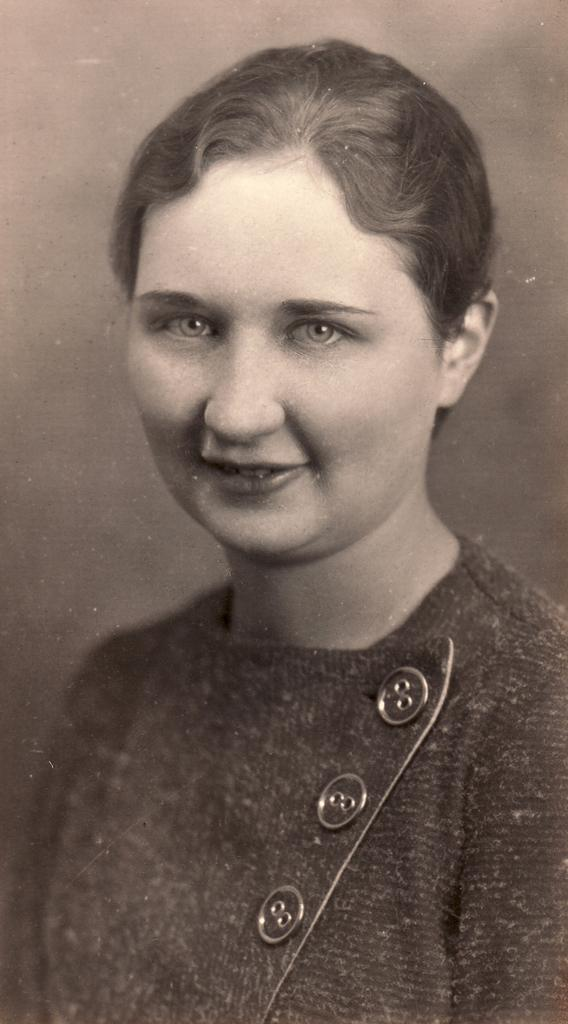What is the color scheme of the image? The image is black and white. Can you describe the main subject in the image? There is a lady in the image. What type of sea creature can be seen in the image? There is no sea creature present in the image; it is a black and white image featuring a lady. What does the caption say in the image? There is no caption present in the image, as it is a photograph and not a text-based image. 